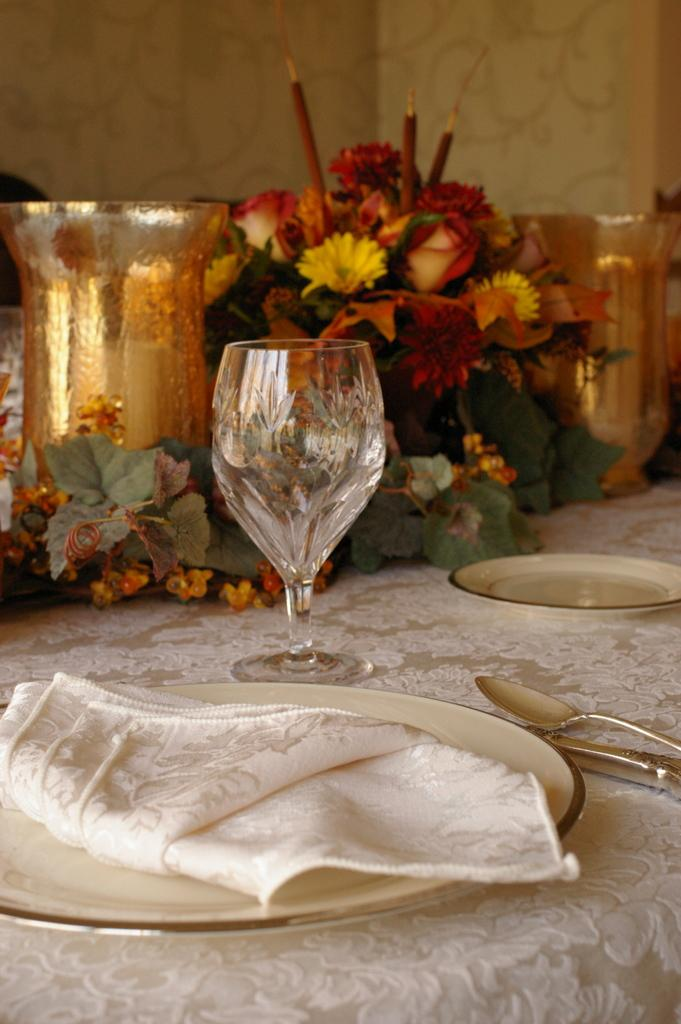What objects can be seen on the dining table in the image? There are plates, spoons, wine glasses, and flowers on the dining table in the image. What type of utensils are present on the dining table? Spoons are present on the dining table. What type of decoration can be seen on the dining table? Flowers are present on the dining table as a decoration. What type of shirt is being worn by the zephyr in the image? There is no zephyr or shirt present in the image. 